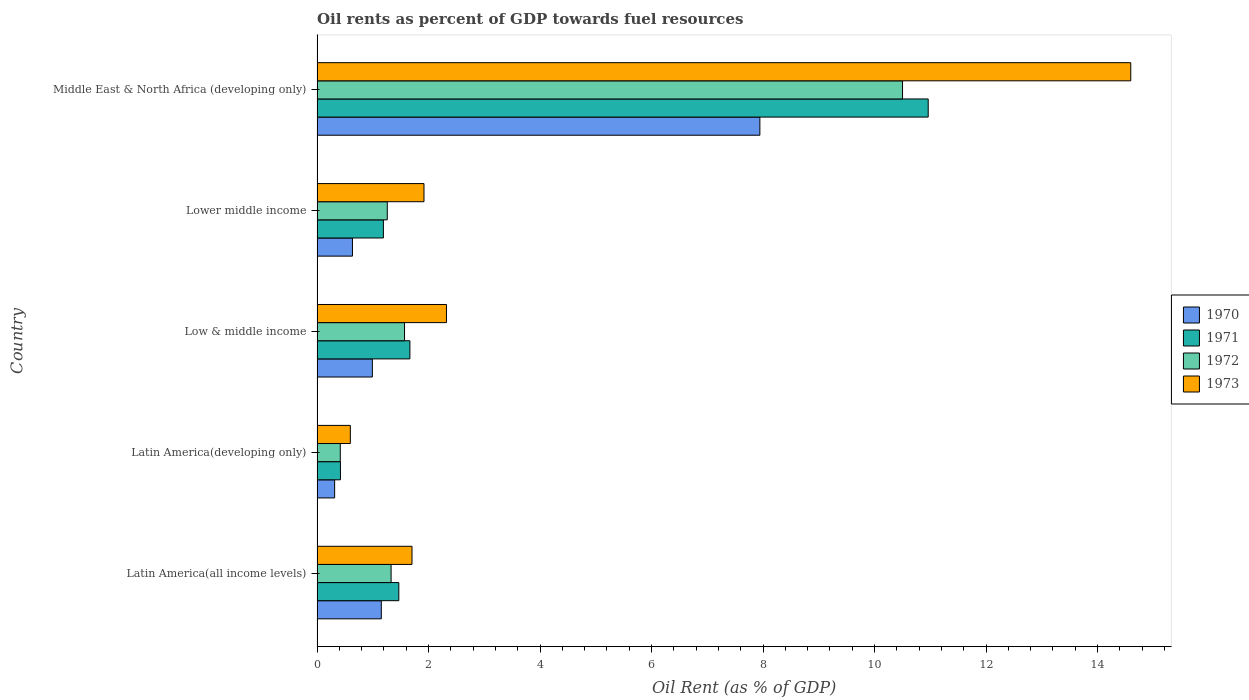How many different coloured bars are there?
Give a very brief answer. 4. Are the number of bars per tick equal to the number of legend labels?
Keep it short and to the point. Yes. Are the number of bars on each tick of the Y-axis equal?
Give a very brief answer. Yes. What is the label of the 2nd group of bars from the top?
Provide a succinct answer. Lower middle income. In how many cases, is the number of bars for a given country not equal to the number of legend labels?
Give a very brief answer. 0. What is the oil rent in 1970 in Low & middle income?
Make the answer very short. 0.99. Across all countries, what is the maximum oil rent in 1972?
Make the answer very short. 10.5. Across all countries, what is the minimum oil rent in 1971?
Your answer should be compact. 0.42. In which country was the oil rent in 1973 maximum?
Offer a terse response. Middle East & North Africa (developing only). In which country was the oil rent in 1970 minimum?
Your response must be concise. Latin America(developing only). What is the total oil rent in 1972 in the graph?
Your response must be concise. 15.08. What is the difference between the oil rent in 1972 in Latin America(all income levels) and that in Low & middle income?
Give a very brief answer. -0.24. What is the difference between the oil rent in 1970 in Latin America(developing only) and the oil rent in 1971 in Low & middle income?
Offer a very short reply. -1.35. What is the average oil rent in 1971 per country?
Your answer should be very brief. 3.14. What is the difference between the oil rent in 1970 and oil rent in 1973 in Middle East & North Africa (developing only)?
Offer a terse response. -6.65. What is the ratio of the oil rent in 1970 in Low & middle income to that in Lower middle income?
Ensure brevity in your answer.  1.56. Is the oil rent in 1972 in Latin America(all income levels) less than that in Latin America(developing only)?
Provide a short and direct response. No. What is the difference between the highest and the second highest oil rent in 1972?
Your answer should be compact. 8.93. What is the difference between the highest and the lowest oil rent in 1972?
Your response must be concise. 10.09. Is the sum of the oil rent in 1970 in Latin America(developing only) and Low & middle income greater than the maximum oil rent in 1973 across all countries?
Your answer should be very brief. No. Is it the case that in every country, the sum of the oil rent in 1972 and oil rent in 1970 is greater than the sum of oil rent in 1971 and oil rent in 1973?
Give a very brief answer. No. What does the 1st bar from the top in Low & middle income represents?
Your answer should be very brief. 1973. What does the 3rd bar from the bottom in Low & middle income represents?
Your answer should be compact. 1972. Is it the case that in every country, the sum of the oil rent in 1973 and oil rent in 1972 is greater than the oil rent in 1970?
Your answer should be compact. Yes. How many bars are there?
Keep it short and to the point. 20. How many countries are there in the graph?
Your response must be concise. 5. What is the difference between two consecutive major ticks on the X-axis?
Provide a short and direct response. 2. Are the values on the major ticks of X-axis written in scientific E-notation?
Provide a succinct answer. No. Does the graph contain grids?
Provide a short and direct response. No. Where does the legend appear in the graph?
Provide a succinct answer. Center right. How many legend labels are there?
Provide a succinct answer. 4. How are the legend labels stacked?
Provide a succinct answer. Vertical. What is the title of the graph?
Your answer should be very brief. Oil rents as percent of GDP towards fuel resources. Does "1960" appear as one of the legend labels in the graph?
Ensure brevity in your answer.  No. What is the label or title of the X-axis?
Provide a succinct answer. Oil Rent (as % of GDP). What is the label or title of the Y-axis?
Give a very brief answer. Country. What is the Oil Rent (as % of GDP) of 1970 in Latin America(all income levels)?
Your response must be concise. 1.15. What is the Oil Rent (as % of GDP) in 1971 in Latin America(all income levels)?
Offer a very short reply. 1.47. What is the Oil Rent (as % of GDP) of 1972 in Latin America(all income levels)?
Provide a succinct answer. 1.33. What is the Oil Rent (as % of GDP) in 1973 in Latin America(all income levels)?
Provide a short and direct response. 1.7. What is the Oil Rent (as % of GDP) of 1970 in Latin America(developing only)?
Provide a short and direct response. 0.32. What is the Oil Rent (as % of GDP) of 1971 in Latin America(developing only)?
Provide a short and direct response. 0.42. What is the Oil Rent (as % of GDP) of 1972 in Latin America(developing only)?
Your response must be concise. 0.42. What is the Oil Rent (as % of GDP) in 1973 in Latin America(developing only)?
Make the answer very short. 0.6. What is the Oil Rent (as % of GDP) of 1970 in Low & middle income?
Keep it short and to the point. 0.99. What is the Oil Rent (as % of GDP) of 1971 in Low & middle income?
Provide a short and direct response. 1.67. What is the Oil Rent (as % of GDP) in 1972 in Low & middle income?
Offer a terse response. 1.57. What is the Oil Rent (as % of GDP) in 1973 in Low & middle income?
Ensure brevity in your answer.  2.32. What is the Oil Rent (as % of GDP) in 1970 in Lower middle income?
Give a very brief answer. 0.63. What is the Oil Rent (as % of GDP) of 1971 in Lower middle income?
Make the answer very short. 1.19. What is the Oil Rent (as % of GDP) of 1972 in Lower middle income?
Your answer should be compact. 1.26. What is the Oil Rent (as % of GDP) in 1973 in Lower middle income?
Your answer should be very brief. 1.92. What is the Oil Rent (as % of GDP) of 1970 in Middle East & North Africa (developing only)?
Your answer should be very brief. 7.94. What is the Oil Rent (as % of GDP) in 1971 in Middle East & North Africa (developing only)?
Your answer should be very brief. 10.96. What is the Oil Rent (as % of GDP) of 1972 in Middle East & North Africa (developing only)?
Offer a terse response. 10.5. What is the Oil Rent (as % of GDP) of 1973 in Middle East & North Africa (developing only)?
Provide a short and direct response. 14.6. Across all countries, what is the maximum Oil Rent (as % of GDP) of 1970?
Your answer should be very brief. 7.94. Across all countries, what is the maximum Oil Rent (as % of GDP) of 1971?
Make the answer very short. 10.96. Across all countries, what is the maximum Oil Rent (as % of GDP) of 1972?
Ensure brevity in your answer.  10.5. Across all countries, what is the maximum Oil Rent (as % of GDP) in 1973?
Offer a very short reply. 14.6. Across all countries, what is the minimum Oil Rent (as % of GDP) of 1970?
Your response must be concise. 0.32. Across all countries, what is the minimum Oil Rent (as % of GDP) of 1971?
Provide a succinct answer. 0.42. Across all countries, what is the minimum Oil Rent (as % of GDP) of 1972?
Your response must be concise. 0.42. Across all countries, what is the minimum Oil Rent (as % of GDP) of 1973?
Ensure brevity in your answer.  0.6. What is the total Oil Rent (as % of GDP) in 1970 in the graph?
Provide a short and direct response. 11.04. What is the total Oil Rent (as % of GDP) in 1971 in the graph?
Give a very brief answer. 15.7. What is the total Oil Rent (as % of GDP) in 1972 in the graph?
Give a very brief answer. 15.08. What is the total Oil Rent (as % of GDP) of 1973 in the graph?
Give a very brief answer. 21.14. What is the difference between the Oil Rent (as % of GDP) of 1970 in Latin America(all income levels) and that in Latin America(developing only)?
Provide a short and direct response. 0.84. What is the difference between the Oil Rent (as % of GDP) of 1971 in Latin America(all income levels) and that in Latin America(developing only)?
Provide a short and direct response. 1.05. What is the difference between the Oil Rent (as % of GDP) in 1972 in Latin America(all income levels) and that in Latin America(developing only)?
Your answer should be very brief. 0.91. What is the difference between the Oil Rent (as % of GDP) of 1973 in Latin America(all income levels) and that in Latin America(developing only)?
Provide a short and direct response. 1.11. What is the difference between the Oil Rent (as % of GDP) in 1970 in Latin America(all income levels) and that in Low & middle income?
Offer a terse response. 0.16. What is the difference between the Oil Rent (as % of GDP) of 1971 in Latin America(all income levels) and that in Low & middle income?
Your response must be concise. -0.2. What is the difference between the Oil Rent (as % of GDP) of 1972 in Latin America(all income levels) and that in Low & middle income?
Ensure brevity in your answer.  -0.24. What is the difference between the Oil Rent (as % of GDP) of 1973 in Latin America(all income levels) and that in Low & middle income?
Your response must be concise. -0.62. What is the difference between the Oil Rent (as % of GDP) in 1970 in Latin America(all income levels) and that in Lower middle income?
Offer a terse response. 0.52. What is the difference between the Oil Rent (as % of GDP) of 1971 in Latin America(all income levels) and that in Lower middle income?
Your answer should be very brief. 0.28. What is the difference between the Oil Rent (as % of GDP) in 1972 in Latin America(all income levels) and that in Lower middle income?
Ensure brevity in your answer.  0.07. What is the difference between the Oil Rent (as % of GDP) in 1973 in Latin America(all income levels) and that in Lower middle income?
Make the answer very short. -0.21. What is the difference between the Oil Rent (as % of GDP) of 1970 in Latin America(all income levels) and that in Middle East & North Africa (developing only)?
Offer a very short reply. -6.79. What is the difference between the Oil Rent (as % of GDP) in 1971 in Latin America(all income levels) and that in Middle East & North Africa (developing only)?
Your answer should be very brief. -9.5. What is the difference between the Oil Rent (as % of GDP) of 1972 in Latin America(all income levels) and that in Middle East & North Africa (developing only)?
Provide a short and direct response. -9.17. What is the difference between the Oil Rent (as % of GDP) in 1973 in Latin America(all income levels) and that in Middle East & North Africa (developing only)?
Offer a very short reply. -12.89. What is the difference between the Oil Rent (as % of GDP) of 1970 in Latin America(developing only) and that in Low & middle income?
Offer a terse response. -0.68. What is the difference between the Oil Rent (as % of GDP) in 1971 in Latin America(developing only) and that in Low & middle income?
Your answer should be compact. -1.25. What is the difference between the Oil Rent (as % of GDP) of 1972 in Latin America(developing only) and that in Low & middle income?
Offer a very short reply. -1.15. What is the difference between the Oil Rent (as % of GDP) of 1973 in Latin America(developing only) and that in Low & middle income?
Your answer should be very brief. -1.72. What is the difference between the Oil Rent (as % of GDP) in 1970 in Latin America(developing only) and that in Lower middle income?
Make the answer very short. -0.32. What is the difference between the Oil Rent (as % of GDP) of 1971 in Latin America(developing only) and that in Lower middle income?
Make the answer very short. -0.77. What is the difference between the Oil Rent (as % of GDP) of 1972 in Latin America(developing only) and that in Lower middle income?
Your answer should be compact. -0.84. What is the difference between the Oil Rent (as % of GDP) of 1973 in Latin America(developing only) and that in Lower middle income?
Ensure brevity in your answer.  -1.32. What is the difference between the Oil Rent (as % of GDP) in 1970 in Latin America(developing only) and that in Middle East & North Africa (developing only)?
Keep it short and to the point. -7.63. What is the difference between the Oil Rent (as % of GDP) of 1971 in Latin America(developing only) and that in Middle East & North Africa (developing only)?
Provide a succinct answer. -10.54. What is the difference between the Oil Rent (as % of GDP) of 1972 in Latin America(developing only) and that in Middle East & North Africa (developing only)?
Offer a very short reply. -10.09. What is the difference between the Oil Rent (as % of GDP) in 1973 in Latin America(developing only) and that in Middle East & North Africa (developing only)?
Provide a short and direct response. -14. What is the difference between the Oil Rent (as % of GDP) in 1970 in Low & middle income and that in Lower middle income?
Make the answer very short. 0.36. What is the difference between the Oil Rent (as % of GDP) of 1971 in Low & middle income and that in Lower middle income?
Offer a terse response. 0.48. What is the difference between the Oil Rent (as % of GDP) of 1972 in Low & middle income and that in Lower middle income?
Your response must be concise. 0.31. What is the difference between the Oil Rent (as % of GDP) in 1973 in Low & middle income and that in Lower middle income?
Give a very brief answer. 0.4. What is the difference between the Oil Rent (as % of GDP) in 1970 in Low & middle income and that in Middle East & North Africa (developing only)?
Keep it short and to the point. -6.95. What is the difference between the Oil Rent (as % of GDP) in 1971 in Low & middle income and that in Middle East & North Africa (developing only)?
Ensure brevity in your answer.  -9.3. What is the difference between the Oil Rent (as % of GDP) of 1972 in Low & middle income and that in Middle East & North Africa (developing only)?
Your answer should be very brief. -8.93. What is the difference between the Oil Rent (as % of GDP) in 1973 in Low & middle income and that in Middle East & North Africa (developing only)?
Offer a very short reply. -12.28. What is the difference between the Oil Rent (as % of GDP) in 1970 in Lower middle income and that in Middle East & North Africa (developing only)?
Make the answer very short. -7.31. What is the difference between the Oil Rent (as % of GDP) of 1971 in Lower middle income and that in Middle East & North Africa (developing only)?
Ensure brevity in your answer.  -9.77. What is the difference between the Oil Rent (as % of GDP) of 1972 in Lower middle income and that in Middle East & North Africa (developing only)?
Your response must be concise. -9.24. What is the difference between the Oil Rent (as % of GDP) in 1973 in Lower middle income and that in Middle East & North Africa (developing only)?
Provide a succinct answer. -12.68. What is the difference between the Oil Rent (as % of GDP) of 1970 in Latin America(all income levels) and the Oil Rent (as % of GDP) of 1971 in Latin America(developing only)?
Offer a very short reply. 0.73. What is the difference between the Oil Rent (as % of GDP) in 1970 in Latin America(all income levels) and the Oil Rent (as % of GDP) in 1972 in Latin America(developing only)?
Offer a very short reply. 0.74. What is the difference between the Oil Rent (as % of GDP) in 1970 in Latin America(all income levels) and the Oil Rent (as % of GDP) in 1973 in Latin America(developing only)?
Offer a very short reply. 0.56. What is the difference between the Oil Rent (as % of GDP) of 1971 in Latin America(all income levels) and the Oil Rent (as % of GDP) of 1972 in Latin America(developing only)?
Offer a terse response. 1.05. What is the difference between the Oil Rent (as % of GDP) in 1971 in Latin America(all income levels) and the Oil Rent (as % of GDP) in 1973 in Latin America(developing only)?
Your response must be concise. 0.87. What is the difference between the Oil Rent (as % of GDP) of 1972 in Latin America(all income levels) and the Oil Rent (as % of GDP) of 1973 in Latin America(developing only)?
Provide a short and direct response. 0.73. What is the difference between the Oil Rent (as % of GDP) of 1970 in Latin America(all income levels) and the Oil Rent (as % of GDP) of 1971 in Low & middle income?
Provide a succinct answer. -0.51. What is the difference between the Oil Rent (as % of GDP) in 1970 in Latin America(all income levels) and the Oil Rent (as % of GDP) in 1972 in Low & middle income?
Offer a very short reply. -0.42. What is the difference between the Oil Rent (as % of GDP) in 1970 in Latin America(all income levels) and the Oil Rent (as % of GDP) in 1973 in Low & middle income?
Your response must be concise. -1.17. What is the difference between the Oil Rent (as % of GDP) of 1971 in Latin America(all income levels) and the Oil Rent (as % of GDP) of 1972 in Low & middle income?
Provide a succinct answer. -0.1. What is the difference between the Oil Rent (as % of GDP) in 1971 in Latin America(all income levels) and the Oil Rent (as % of GDP) in 1973 in Low & middle income?
Keep it short and to the point. -0.85. What is the difference between the Oil Rent (as % of GDP) in 1972 in Latin America(all income levels) and the Oil Rent (as % of GDP) in 1973 in Low & middle income?
Provide a succinct answer. -0.99. What is the difference between the Oil Rent (as % of GDP) of 1970 in Latin America(all income levels) and the Oil Rent (as % of GDP) of 1971 in Lower middle income?
Make the answer very short. -0.04. What is the difference between the Oil Rent (as % of GDP) of 1970 in Latin America(all income levels) and the Oil Rent (as % of GDP) of 1972 in Lower middle income?
Your answer should be very brief. -0.11. What is the difference between the Oil Rent (as % of GDP) of 1970 in Latin America(all income levels) and the Oil Rent (as % of GDP) of 1973 in Lower middle income?
Keep it short and to the point. -0.77. What is the difference between the Oil Rent (as % of GDP) in 1971 in Latin America(all income levels) and the Oil Rent (as % of GDP) in 1972 in Lower middle income?
Offer a terse response. 0.21. What is the difference between the Oil Rent (as % of GDP) of 1971 in Latin America(all income levels) and the Oil Rent (as % of GDP) of 1973 in Lower middle income?
Keep it short and to the point. -0.45. What is the difference between the Oil Rent (as % of GDP) in 1972 in Latin America(all income levels) and the Oil Rent (as % of GDP) in 1973 in Lower middle income?
Give a very brief answer. -0.59. What is the difference between the Oil Rent (as % of GDP) in 1970 in Latin America(all income levels) and the Oil Rent (as % of GDP) in 1971 in Middle East & North Africa (developing only)?
Provide a succinct answer. -9.81. What is the difference between the Oil Rent (as % of GDP) of 1970 in Latin America(all income levels) and the Oil Rent (as % of GDP) of 1972 in Middle East & North Africa (developing only)?
Give a very brief answer. -9.35. What is the difference between the Oil Rent (as % of GDP) of 1970 in Latin America(all income levels) and the Oil Rent (as % of GDP) of 1973 in Middle East & North Africa (developing only)?
Your answer should be very brief. -13.44. What is the difference between the Oil Rent (as % of GDP) of 1971 in Latin America(all income levels) and the Oil Rent (as % of GDP) of 1972 in Middle East & North Africa (developing only)?
Make the answer very short. -9.04. What is the difference between the Oil Rent (as % of GDP) in 1971 in Latin America(all income levels) and the Oil Rent (as % of GDP) in 1973 in Middle East & North Africa (developing only)?
Your answer should be very brief. -13.13. What is the difference between the Oil Rent (as % of GDP) of 1972 in Latin America(all income levels) and the Oil Rent (as % of GDP) of 1973 in Middle East & North Africa (developing only)?
Ensure brevity in your answer.  -13.27. What is the difference between the Oil Rent (as % of GDP) in 1970 in Latin America(developing only) and the Oil Rent (as % of GDP) in 1971 in Low & middle income?
Make the answer very short. -1.35. What is the difference between the Oil Rent (as % of GDP) of 1970 in Latin America(developing only) and the Oil Rent (as % of GDP) of 1972 in Low & middle income?
Keep it short and to the point. -1.25. What is the difference between the Oil Rent (as % of GDP) of 1970 in Latin America(developing only) and the Oil Rent (as % of GDP) of 1973 in Low & middle income?
Provide a short and direct response. -2.01. What is the difference between the Oil Rent (as % of GDP) of 1971 in Latin America(developing only) and the Oil Rent (as % of GDP) of 1972 in Low & middle income?
Your response must be concise. -1.15. What is the difference between the Oil Rent (as % of GDP) in 1971 in Latin America(developing only) and the Oil Rent (as % of GDP) in 1973 in Low & middle income?
Keep it short and to the point. -1.9. What is the difference between the Oil Rent (as % of GDP) of 1972 in Latin America(developing only) and the Oil Rent (as % of GDP) of 1973 in Low & middle income?
Give a very brief answer. -1.9. What is the difference between the Oil Rent (as % of GDP) of 1970 in Latin America(developing only) and the Oil Rent (as % of GDP) of 1971 in Lower middle income?
Ensure brevity in your answer.  -0.87. What is the difference between the Oil Rent (as % of GDP) in 1970 in Latin America(developing only) and the Oil Rent (as % of GDP) in 1972 in Lower middle income?
Provide a short and direct response. -0.94. What is the difference between the Oil Rent (as % of GDP) of 1970 in Latin America(developing only) and the Oil Rent (as % of GDP) of 1973 in Lower middle income?
Make the answer very short. -1.6. What is the difference between the Oil Rent (as % of GDP) in 1971 in Latin America(developing only) and the Oil Rent (as % of GDP) in 1972 in Lower middle income?
Your response must be concise. -0.84. What is the difference between the Oil Rent (as % of GDP) in 1971 in Latin America(developing only) and the Oil Rent (as % of GDP) in 1973 in Lower middle income?
Your answer should be very brief. -1.5. What is the difference between the Oil Rent (as % of GDP) in 1972 in Latin America(developing only) and the Oil Rent (as % of GDP) in 1973 in Lower middle income?
Ensure brevity in your answer.  -1.5. What is the difference between the Oil Rent (as % of GDP) in 1970 in Latin America(developing only) and the Oil Rent (as % of GDP) in 1971 in Middle East & North Africa (developing only)?
Provide a short and direct response. -10.65. What is the difference between the Oil Rent (as % of GDP) in 1970 in Latin America(developing only) and the Oil Rent (as % of GDP) in 1972 in Middle East & North Africa (developing only)?
Provide a short and direct response. -10.19. What is the difference between the Oil Rent (as % of GDP) of 1970 in Latin America(developing only) and the Oil Rent (as % of GDP) of 1973 in Middle East & North Africa (developing only)?
Your answer should be compact. -14.28. What is the difference between the Oil Rent (as % of GDP) in 1971 in Latin America(developing only) and the Oil Rent (as % of GDP) in 1972 in Middle East & North Africa (developing only)?
Provide a short and direct response. -10.08. What is the difference between the Oil Rent (as % of GDP) in 1971 in Latin America(developing only) and the Oil Rent (as % of GDP) in 1973 in Middle East & North Africa (developing only)?
Your response must be concise. -14.18. What is the difference between the Oil Rent (as % of GDP) of 1972 in Latin America(developing only) and the Oil Rent (as % of GDP) of 1973 in Middle East & North Africa (developing only)?
Your response must be concise. -14.18. What is the difference between the Oil Rent (as % of GDP) of 1970 in Low & middle income and the Oil Rent (as % of GDP) of 1971 in Lower middle income?
Make the answer very short. -0.2. What is the difference between the Oil Rent (as % of GDP) in 1970 in Low & middle income and the Oil Rent (as % of GDP) in 1972 in Lower middle income?
Your answer should be very brief. -0.27. What is the difference between the Oil Rent (as % of GDP) in 1970 in Low & middle income and the Oil Rent (as % of GDP) in 1973 in Lower middle income?
Make the answer very short. -0.93. What is the difference between the Oil Rent (as % of GDP) of 1971 in Low & middle income and the Oil Rent (as % of GDP) of 1972 in Lower middle income?
Provide a succinct answer. 0.41. What is the difference between the Oil Rent (as % of GDP) in 1971 in Low & middle income and the Oil Rent (as % of GDP) in 1973 in Lower middle income?
Offer a very short reply. -0.25. What is the difference between the Oil Rent (as % of GDP) in 1972 in Low & middle income and the Oil Rent (as % of GDP) in 1973 in Lower middle income?
Provide a short and direct response. -0.35. What is the difference between the Oil Rent (as % of GDP) in 1970 in Low & middle income and the Oil Rent (as % of GDP) in 1971 in Middle East & North Africa (developing only)?
Your answer should be very brief. -9.97. What is the difference between the Oil Rent (as % of GDP) in 1970 in Low & middle income and the Oil Rent (as % of GDP) in 1972 in Middle East & North Africa (developing only)?
Keep it short and to the point. -9.51. What is the difference between the Oil Rent (as % of GDP) in 1970 in Low & middle income and the Oil Rent (as % of GDP) in 1973 in Middle East & North Africa (developing only)?
Provide a succinct answer. -13.6. What is the difference between the Oil Rent (as % of GDP) in 1971 in Low & middle income and the Oil Rent (as % of GDP) in 1972 in Middle East & North Africa (developing only)?
Ensure brevity in your answer.  -8.84. What is the difference between the Oil Rent (as % of GDP) in 1971 in Low & middle income and the Oil Rent (as % of GDP) in 1973 in Middle East & North Africa (developing only)?
Your answer should be very brief. -12.93. What is the difference between the Oil Rent (as % of GDP) of 1972 in Low & middle income and the Oil Rent (as % of GDP) of 1973 in Middle East & North Africa (developing only)?
Provide a succinct answer. -13.03. What is the difference between the Oil Rent (as % of GDP) of 1970 in Lower middle income and the Oil Rent (as % of GDP) of 1971 in Middle East & North Africa (developing only)?
Ensure brevity in your answer.  -10.33. What is the difference between the Oil Rent (as % of GDP) in 1970 in Lower middle income and the Oil Rent (as % of GDP) in 1972 in Middle East & North Africa (developing only)?
Provide a succinct answer. -9.87. What is the difference between the Oil Rent (as % of GDP) in 1970 in Lower middle income and the Oil Rent (as % of GDP) in 1973 in Middle East & North Africa (developing only)?
Your response must be concise. -13.96. What is the difference between the Oil Rent (as % of GDP) in 1971 in Lower middle income and the Oil Rent (as % of GDP) in 1972 in Middle East & North Africa (developing only)?
Keep it short and to the point. -9.31. What is the difference between the Oil Rent (as % of GDP) in 1971 in Lower middle income and the Oil Rent (as % of GDP) in 1973 in Middle East & North Africa (developing only)?
Give a very brief answer. -13.41. What is the difference between the Oil Rent (as % of GDP) of 1972 in Lower middle income and the Oil Rent (as % of GDP) of 1973 in Middle East & North Africa (developing only)?
Give a very brief answer. -13.34. What is the average Oil Rent (as % of GDP) in 1970 per country?
Make the answer very short. 2.21. What is the average Oil Rent (as % of GDP) of 1971 per country?
Offer a very short reply. 3.14. What is the average Oil Rent (as % of GDP) of 1972 per country?
Keep it short and to the point. 3.02. What is the average Oil Rent (as % of GDP) of 1973 per country?
Offer a terse response. 4.23. What is the difference between the Oil Rent (as % of GDP) in 1970 and Oil Rent (as % of GDP) in 1971 in Latin America(all income levels)?
Ensure brevity in your answer.  -0.31. What is the difference between the Oil Rent (as % of GDP) of 1970 and Oil Rent (as % of GDP) of 1972 in Latin America(all income levels)?
Ensure brevity in your answer.  -0.18. What is the difference between the Oil Rent (as % of GDP) in 1970 and Oil Rent (as % of GDP) in 1973 in Latin America(all income levels)?
Provide a succinct answer. -0.55. What is the difference between the Oil Rent (as % of GDP) of 1971 and Oil Rent (as % of GDP) of 1972 in Latin America(all income levels)?
Offer a terse response. 0.14. What is the difference between the Oil Rent (as % of GDP) in 1971 and Oil Rent (as % of GDP) in 1973 in Latin America(all income levels)?
Keep it short and to the point. -0.24. What is the difference between the Oil Rent (as % of GDP) in 1972 and Oil Rent (as % of GDP) in 1973 in Latin America(all income levels)?
Your response must be concise. -0.38. What is the difference between the Oil Rent (as % of GDP) of 1970 and Oil Rent (as % of GDP) of 1971 in Latin America(developing only)?
Provide a succinct answer. -0.1. What is the difference between the Oil Rent (as % of GDP) of 1970 and Oil Rent (as % of GDP) of 1972 in Latin America(developing only)?
Provide a succinct answer. -0.1. What is the difference between the Oil Rent (as % of GDP) of 1970 and Oil Rent (as % of GDP) of 1973 in Latin America(developing only)?
Your answer should be very brief. -0.28. What is the difference between the Oil Rent (as % of GDP) of 1971 and Oil Rent (as % of GDP) of 1972 in Latin America(developing only)?
Make the answer very short. 0. What is the difference between the Oil Rent (as % of GDP) in 1971 and Oil Rent (as % of GDP) in 1973 in Latin America(developing only)?
Offer a very short reply. -0.18. What is the difference between the Oil Rent (as % of GDP) of 1972 and Oil Rent (as % of GDP) of 1973 in Latin America(developing only)?
Offer a terse response. -0.18. What is the difference between the Oil Rent (as % of GDP) in 1970 and Oil Rent (as % of GDP) in 1971 in Low & middle income?
Offer a very short reply. -0.67. What is the difference between the Oil Rent (as % of GDP) in 1970 and Oil Rent (as % of GDP) in 1972 in Low & middle income?
Offer a very short reply. -0.58. What is the difference between the Oil Rent (as % of GDP) in 1970 and Oil Rent (as % of GDP) in 1973 in Low & middle income?
Your response must be concise. -1.33. What is the difference between the Oil Rent (as % of GDP) of 1971 and Oil Rent (as % of GDP) of 1972 in Low & middle income?
Your response must be concise. 0.1. What is the difference between the Oil Rent (as % of GDP) of 1971 and Oil Rent (as % of GDP) of 1973 in Low & middle income?
Provide a succinct answer. -0.66. What is the difference between the Oil Rent (as % of GDP) of 1972 and Oil Rent (as % of GDP) of 1973 in Low & middle income?
Offer a very short reply. -0.75. What is the difference between the Oil Rent (as % of GDP) in 1970 and Oil Rent (as % of GDP) in 1971 in Lower middle income?
Your response must be concise. -0.56. What is the difference between the Oil Rent (as % of GDP) in 1970 and Oil Rent (as % of GDP) in 1972 in Lower middle income?
Your answer should be very brief. -0.62. What is the difference between the Oil Rent (as % of GDP) in 1970 and Oil Rent (as % of GDP) in 1973 in Lower middle income?
Your response must be concise. -1.28. What is the difference between the Oil Rent (as % of GDP) of 1971 and Oil Rent (as % of GDP) of 1972 in Lower middle income?
Provide a short and direct response. -0.07. What is the difference between the Oil Rent (as % of GDP) of 1971 and Oil Rent (as % of GDP) of 1973 in Lower middle income?
Offer a terse response. -0.73. What is the difference between the Oil Rent (as % of GDP) of 1972 and Oil Rent (as % of GDP) of 1973 in Lower middle income?
Offer a very short reply. -0.66. What is the difference between the Oil Rent (as % of GDP) in 1970 and Oil Rent (as % of GDP) in 1971 in Middle East & North Africa (developing only)?
Ensure brevity in your answer.  -3.02. What is the difference between the Oil Rent (as % of GDP) in 1970 and Oil Rent (as % of GDP) in 1972 in Middle East & North Africa (developing only)?
Your response must be concise. -2.56. What is the difference between the Oil Rent (as % of GDP) in 1970 and Oil Rent (as % of GDP) in 1973 in Middle East & North Africa (developing only)?
Provide a short and direct response. -6.65. What is the difference between the Oil Rent (as % of GDP) of 1971 and Oil Rent (as % of GDP) of 1972 in Middle East & North Africa (developing only)?
Make the answer very short. 0.46. What is the difference between the Oil Rent (as % of GDP) of 1971 and Oil Rent (as % of GDP) of 1973 in Middle East & North Africa (developing only)?
Offer a terse response. -3.63. What is the difference between the Oil Rent (as % of GDP) in 1972 and Oil Rent (as % of GDP) in 1973 in Middle East & North Africa (developing only)?
Ensure brevity in your answer.  -4.09. What is the ratio of the Oil Rent (as % of GDP) in 1970 in Latin America(all income levels) to that in Latin America(developing only)?
Your answer should be compact. 3.65. What is the ratio of the Oil Rent (as % of GDP) in 1971 in Latin America(all income levels) to that in Latin America(developing only)?
Provide a short and direct response. 3.5. What is the ratio of the Oil Rent (as % of GDP) in 1972 in Latin America(all income levels) to that in Latin America(developing only)?
Your answer should be compact. 3.19. What is the ratio of the Oil Rent (as % of GDP) of 1973 in Latin America(all income levels) to that in Latin America(developing only)?
Provide a succinct answer. 2.85. What is the ratio of the Oil Rent (as % of GDP) of 1970 in Latin America(all income levels) to that in Low & middle income?
Your response must be concise. 1.16. What is the ratio of the Oil Rent (as % of GDP) in 1971 in Latin America(all income levels) to that in Low & middle income?
Offer a very short reply. 0.88. What is the ratio of the Oil Rent (as % of GDP) of 1972 in Latin America(all income levels) to that in Low & middle income?
Your response must be concise. 0.85. What is the ratio of the Oil Rent (as % of GDP) of 1973 in Latin America(all income levels) to that in Low & middle income?
Offer a terse response. 0.73. What is the ratio of the Oil Rent (as % of GDP) of 1970 in Latin America(all income levels) to that in Lower middle income?
Your answer should be compact. 1.82. What is the ratio of the Oil Rent (as % of GDP) in 1971 in Latin America(all income levels) to that in Lower middle income?
Make the answer very short. 1.23. What is the ratio of the Oil Rent (as % of GDP) of 1972 in Latin America(all income levels) to that in Lower middle income?
Give a very brief answer. 1.05. What is the ratio of the Oil Rent (as % of GDP) of 1973 in Latin America(all income levels) to that in Lower middle income?
Provide a succinct answer. 0.89. What is the ratio of the Oil Rent (as % of GDP) of 1970 in Latin America(all income levels) to that in Middle East & North Africa (developing only)?
Offer a very short reply. 0.15. What is the ratio of the Oil Rent (as % of GDP) in 1971 in Latin America(all income levels) to that in Middle East & North Africa (developing only)?
Offer a very short reply. 0.13. What is the ratio of the Oil Rent (as % of GDP) of 1972 in Latin America(all income levels) to that in Middle East & North Africa (developing only)?
Give a very brief answer. 0.13. What is the ratio of the Oil Rent (as % of GDP) in 1973 in Latin America(all income levels) to that in Middle East & North Africa (developing only)?
Your response must be concise. 0.12. What is the ratio of the Oil Rent (as % of GDP) of 1970 in Latin America(developing only) to that in Low & middle income?
Your answer should be very brief. 0.32. What is the ratio of the Oil Rent (as % of GDP) of 1971 in Latin America(developing only) to that in Low & middle income?
Your answer should be very brief. 0.25. What is the ratio of the Oil Rent (as % of GDP) of 1972 in Latin America(developing only) to that in Low & middle income?
Keep it short and to the point. 0.27. What is the ratio of the Oil Rent (as % of GDP) in 1973 in Latin America(developing only) to that in Low & middle income?
Your answer should be very brief. 0.26. What is the ratio of the Oil Rent (as % of GDP) in 1970 in Latin America(developing only) to that in Lower middle income?
Offer a very short reply. 0.5. What is the ratio of the Oil Rent (as % of GDP) of 1971 in Latin America(developing only) to that in Lower middle income?
Your answer should be compact. 0.35. What is the ratio of the Oil Rent (as % of GDP) of 1972 in Latin America(developing only) to that in Lower middle income?
Make the answer very short. 0.33. What is the ratio of the Oil Rent (as % of GDP) in 1973 in Latin America(developing only) to that in Lower middle income?
Your answer should be compact. 0.31. What is the ratio of the Oil Rent (as % of GDP) of 1970 in Latin America(developing only) to that in Middle East & North Africa (developing only)?
Offer a very short reply. 0.04. What is the ratio of the Oil Rent (as % of GDP) of 1971 in Latin America(developing only) to that in Middle East & North Africa (developing only)?
Provide a short and direct response. 0.04. What is the ratio of the Oil Rent (as % of GDP) of 1972 in Latin America(developing only) to that in Middle East & North Africa (developing only)?
Provide a short and direct response. 0.04. What is the ratio of the Oil Rent (as % of GDP) in 1973 in Latin America(developing only) to that in Middle East & North Africa (developing only)?
Your answer should be compact. 0.04. What is the ratio of the Oil Rent (as % of GDP) in 1970 in Low & middle income to that in Lower middle income?
Offer a terse response. 1.56. What is the ratio of the Oil Rent (as % of GDP) of 1971 in Low & middle income to that in Lower middle income?
Your response must be concise. 1.4. What is the ratio of the Oil Rent (as % of GDP) in 1972 in Low & middle income to that in Lower middle income?
Offer a very short reply. 1.25. What is the ratio of the Oil Rent (as % of GDP) of 1973 in Low & middle income to that in Lower middle income?
Your answer should be compact. 1.21. What is the ratio of the Oil Rent (as % of GDP) of 1970 in Low & middle income to that in Middle East & North Africa (developing only)?
Make the answer very short. 0.12. What is the ratio of the Oil Rent (as % of GDP) of 1971 in Low & middle income to that in Middle East & North Africa (developing only)?
Ensure brevity in your answer.  0.15. What is the ratio of the Oil Rent (as % of GDP) of 1972 in Low & middle income to that in Middle East & North Africa (developing only)?
Offer a very short reply. 0.15. What is the ratio of the Oil Rent (as % of GDP) in 1973 in Low & middle income to that in Middle East & North Africa (developing only)?
Your answer should be very brief. 0.16. What is the ratio of the Oil Rent (as % of GDP) in 1970 in Lower middle income to that in Middle East & North Africa (developing only)?
Give a very brief answer. 0.08. What is the ratio of the Oil Rent (as % of GDP) of 1971 in Lower middle income to that in Middle East & North Africa (developing only)?
Your answer should be compact. 0.11. What is the ratio of the Oil Rent (as % of GDP) in 1972 in Lower middle income to that in Middle East & North Africa (developing only)?
Your answer should be compact. 0.12. What is the ratio of the Oil Rent (as % of GDP) in 1973 in Lower middle income to that in Middle East & North Africa (developing only)?
Your response must be concise. 0.13. What is the difference between the highest and the second highest Oil Rent (as % of GDP) in 1970?
Ensure brevity in your answer.  6.79. What is the difference between the highest and the second highest Oil Rent (as % of GDP) in 1971?
Your response must be concise. 9.3. What is the difference between the highest and the second highest Oil Rent (as % of GDP) in 1972?
Make the answer very short. 8.93. What is the difference between the highest and the second highest Oil Rent (as % of GDP) of 1973?
Ensure brevity in your answer.  12.28. What is the difference between the highest and the lowest Oil Rent (as % of GDP) in 1970?
Make the answer very short. 7.63. What is the difference between the highest and the lowest Oil Rent (as % of GDP) of 1971?
Give a very brief answer. 10.54. What is the difference between the highest and the lowest Oil Rent (as % of GDP) of 1972?
Ensure brevity in your answer.  10.09. What is the difference between the highest and the lowest Oil Rent (as % of GDP) in 1973?
Provide a short and direct response. 14. 